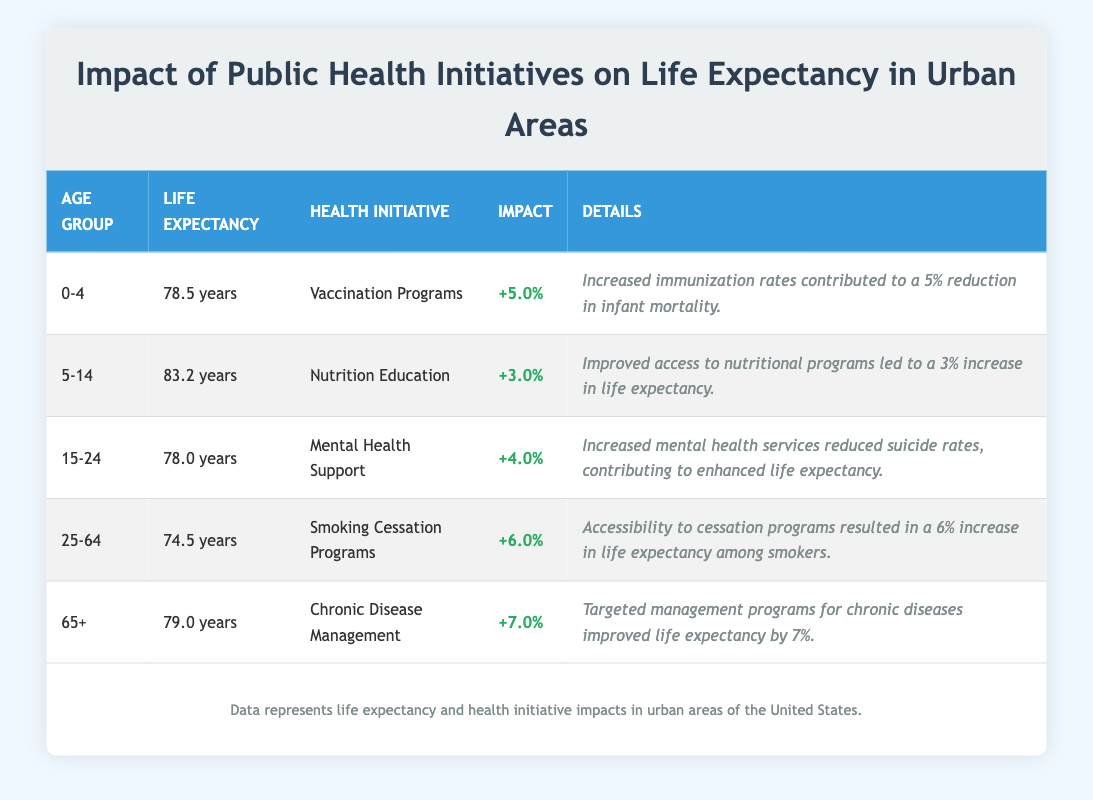What is the life expectancy for the age group 25-64? The life expectancy for the age group 25-64 is directly listed in the table under "Life Expectancy". It shows as 74.5 years.
Answer: 74.5 years Which health initiative contributed to the highest increase in life expectancy? By examining the "Impact" column for all age groups, Chronic Disease Management has the highest impact percentage at 7.0%, indicating it contributed the most to life expectancy.
Answer: Chronic Disease Management Is the statement true or false: Smoking Cessation Programs have a higher impact on life expectancy than Nutrition Education? Comparing the impact percentages, Smoking Cessation Programs have an impact of 6.0% while Nutrition Education has 3.0%. Since 6.0% is greater than 3.0%, the statement is true.
Answer: True What is the average life expectancy across all the age groups listed? We begin by summing the life expectancies: 78.5 + 83.2 + 78.0 + 74.5 + 79.0 = 393.2. There are 5 age groups, so we divide 393.2 by 5, which gives us an average life expectancy of 78.64 years.
Answer: 78.64 years How much does the life expectancy for the age group 15-24 exceed that of the age group 25-64? We find the life expectancy for age group 15-24, which is 78.0 years, and for 25-64, which is 74.5 years. Then, we calculate 78.0 - 74.5 = 3.5 years, indicating that the 15-24 age group has a higher life expectancy by this amount.
Answer: 3.5 years For which age group is the improvement due to health initiatives the least? Looking at the "Impact" column, Nutrition Education with a 3.0% increase is the lowest percentage among all health initiatives across the age groups.
Answer: Age group 5-14 What health initiative aimed at improving the life expectancy of individuals aged 65 and older? The table indicates that Chronic Disease Management is the health initiative specifically targeting the 65+ age group, aimed at improving their life expectancy.
Answer: Chronic Disease Management Does the life expectancy for age group 0-4 benefit from health initiatives? Yes, the life expectancy for the age group 0-4 is supported by the Vaccination Programs which contribute a 5.0% increase in life expectancy.
Answer: Yes 